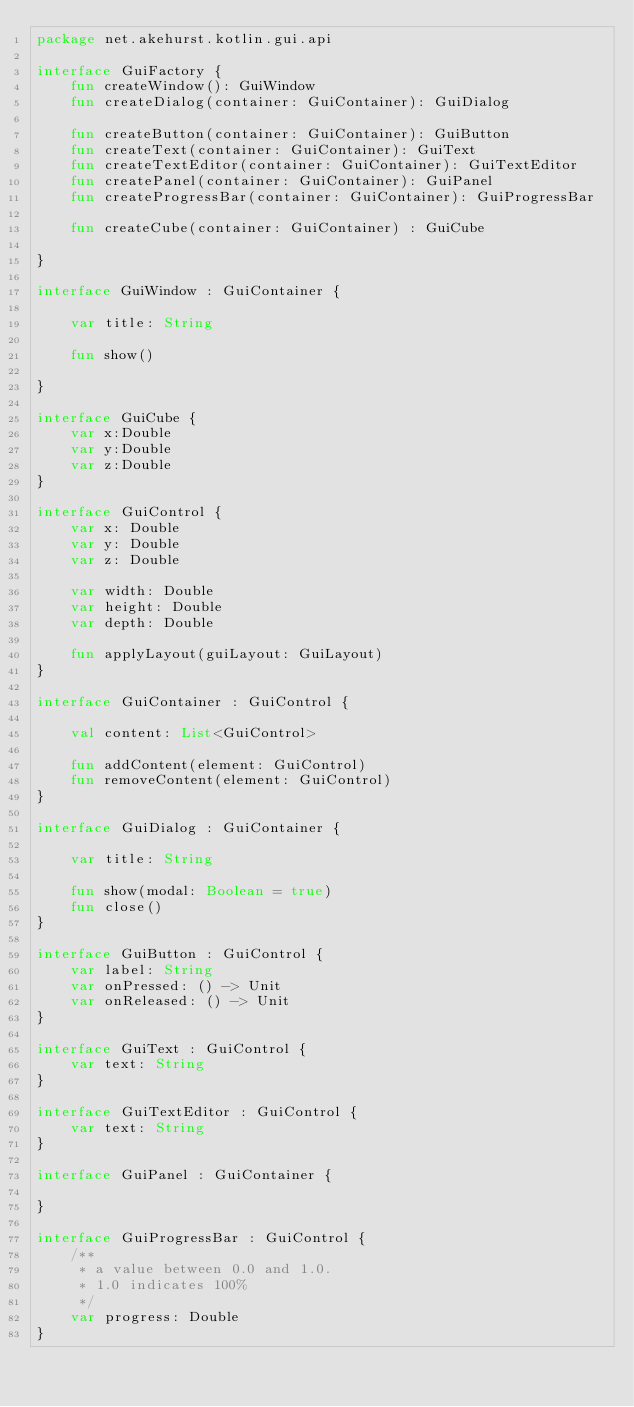Convert code to text. <code><loc_0><loc_0><loc_500><loc_500><_Kotlin_>package net.akehurst.kotlin.gui.api

interface GuiFactory {
    fun createWindow(): GuiWindow
    fun createDialog(container: GuiContainer): GuiDialog

    fun createButton(container: GuiContainer): GuiButton
    fun createText(container: GuiContainer): GuiText
    fun createTextEditor(container: GuiContainer): GuiTextEditor
    fun createPanel(container: GuiContainer): GuiPanel
    fun createProgressBar(container: GuiContainer): GuiProgressBar

    fun createCube(container: GuiContainer) : GuiCube

}

interface GuiWindow : GuiContainer {

    var title: String

    fun show()

}

interface GuiCube {
    var x:Double
    var y:Double
    var z:Double
}

interface GuiControl {
    var x: Double
    var y: Double
    var z: Double

    var width: Double
    var height: Double
    var depth: Double

    fun applyLayout(guiLayout: GuiLayout)
}

interface GuiContainer : GuiControl {

    val content: List<GuiControl>

    fun addContent(element: GuiControl)
    fun removeContent(element: GuiControl)
}

interface GuiDialog : GuiContainer {

    var title: String

    fun show(modal: Boolean = true)
    fun close()
}

interface GuiButton : GuiControl {
    var label: String
    var onPressed: () -> Unit
    var onReleased: () -> Unit
}

interface GuiText : GuiControl {
    var text: String
}

interface GuiTextEditor : GuiControl {
    var text: String
}

interface GuiPanel : GuiContainer {

}

interface GuiProgressBar : GuiControl {
    /**
     * a value between 0.0 and 1.0.
     * 1.0 indicates 100%
     */
    var progress: Double
}</code> 